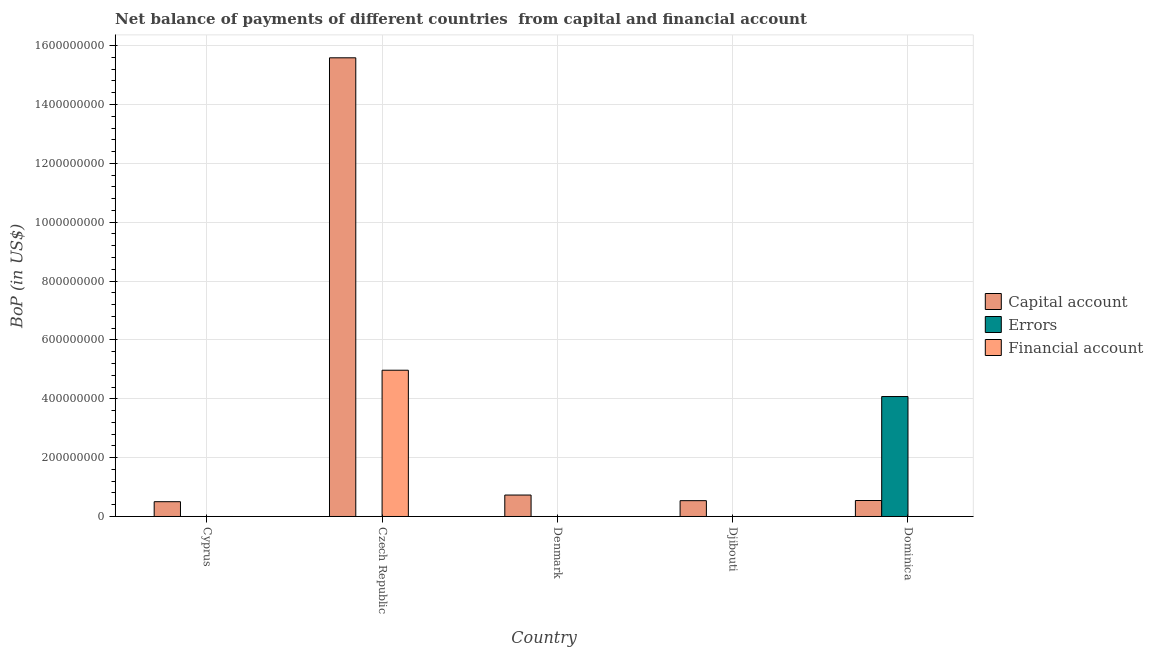How many different coloured bars are there?
Provide a short and direct response. 3. Are the number of bars per tick equal to the number of legend labels?
Make the answer very short. No. Are the number of bars on each tick of the X-axis equal?
Your answer should be very brief. No. How many bars are there on the 3rd tick from the right?
Your response must be concise. 1. What is the label of the 1st group of bars from the left?
Your answer should be compact. Cyprus. In how many cases, is the number of bars for a given country not equal to the number of legend labels?
Ensure brevity in your answer.  5. What is the amount of errors in Cyprus?
Make the answer very short. 0. Across all countries, what is the maximum amount of net capital account?
Offer a very short reply. 1.56e+09. In which country was the amount of net capital account maximum?
Offer a very short reply. Czech Republic. What is the total amount of net capital account in the graph?
Offer a very short reply. 1.79e+09. What is the difference between the amount of net capital account in Denmark and that in Dominica?
Provide a succinct answer. 1.85e+07. What is the average amount of errors per country?
Offer a very short reply. 8.15e+07. In how many countries, is the amount of financial account greater than 680000000 US$?
Provide a succinct answer. 0. Is the amount of net capital account in Cyprus less than that in Dominica?
Your answer should be compact. Yes. What is the difference between the highest and the second highest amount of net capital account?
Your answer should be compact. 1.49e+09. What is the difference between the highest and the lowest amount of financial account?
Keep it short and to the point. 4.97e+08. Are all the bars in the graph horizontal?
Your answer should be very brief. No. Does the graph contain any zero values?
Make the answer very short. Yes. Does the graph contain grids?
Provide a succinct answer. Yes. Where does the legend appear in the graph?
Your answer should be compact. Center right. How many legend labels are there?
Offer a very short reply. 3. What is the title of the graph?
Provide a short and direct response. Net balance of payments of different countries  from capital and financial account. What is the label or title of the X-axis?
Give a very brief answer. Country. What is the label or title of the Y-axis?
Your answer should be compact. BoP (in US$). What is the BoP (in US$) of Capital account in Cyprus?
Your response must be concise. 5.03e+07. What is the BoP (in US$) in Errors in Cyprus?
Give a very brief answer. 0. What is the BoP (in US$) in Financial account in Cyprus?
Give a very brief answer. 0. What is the BoP (in US$) in Capital account in Czech Republic?
Your answer should be compact. 1.56e+09. What is the BoP (in US$) in Errors in Czech Republic?
Your answer should be very brief. 0. What is the BoP (in US$) of Financial account in Czech Republic?
Your answer should be very brief. 4.97e+08. What is the BoP (in US$) in Capital account in Denmark?
Make the answer very short. 7.29e+07. What is the BoP (in US$) in Errors in Denmark?
Make the answer very short. 0. What is the BoP (in US$) of Capital account in Djibouti?
Your answer should be compact. 5.37e+07. What is the BoP (in US$) of Financial account in Djibouti?
Give a very brief answer. 0. What is the BoP (in US$) of Capital account in Dominica?
Offer a very short reply. 5.43e+07. What is the BoP (in US$) in Errors in Dominica?
Ensure brevity in your answer.  4.08e+08. Across all countries, what is the maximum BoP (in US$) in Capital account?
Provide a short and direct response. 1.56e+09. Across all countries, what is the maximum BoP (in US$) of Errors?
Offer a very short reply. 4.08e+08. Across all countries, what is the maximum BoP (in US$) in Financial account?
Keep it short and to the point. 4.97e+08. Across all countries, what is the minimum BoP (in US$) of Capital account?
Ensure brevity in your answer.  5.03e+07. What is the total BoP (in US$) in Capital account in the graph?
Provide a short and direct response. 1.79e+09. What is the total BoP (in US$) of Errors in the graph?
Make the answer very short. 4.08e+08. What is the total BoP (in US$) of Financial account in the graph?
Provide a short and direct response. 4.97e+08. What is the difference between the BoP (in US$) in Capital account in Cyprus and that in Czech Republic?
Your answer should be very brief. -1.51e+09. What is the difference between the BoP (in US$) of Capital account in Cyprus and that in Denmark?
Offer a very short reply. -2.26e+07. What is the difference between the BoP (in US$) in Capital account in Cyprus and that in Djibouti?
Your answer should be compact. -3.47e+06. What is the difference between the BoP (in US$) in Capital account in Cyprus and that in Dominica?
Your response must be concise. -4.03e+06. What is the difference between the BoP (in US$) in Capital account in Czech Republic and that in Denmark?
Give a very brief answer. 1.49e+09. What is the difference between the BoP (in US$) of Capital account in Czech Republic and that in Djibouti?
Keep it short and to the point. 1.50e+09. What is the difference between the BoP (in US$) of Capital account in Czech Republic and that in Dominica?
Keep it short and to the point. 1.50e+09. What is the difference between the BoP (in US$) in Capital account in Denmark and that in Djibouti?
Offer a very short reply. 1.91e+07. What is the difference between the BoP (in US$) in Capital account in Denmark and that in Dominica?
Give a very brief answer. 1.85e+07. What is the difference between the BoP (in US$) in Capital account in Djibouti and that in Dominica?
Provide a short and direct response. -5.60e+05. What is the difference between the BoP (in US$) in Capital account in Cyprus and the BoP (in US$) in Financial account in Czech Republic?
Provide a succinct answer. -4.47e+08. What is the difference between the BoP (in US$) of Capital account in Cyprus and the BoP (in US$) of Errors in Dominica?
Give a very brief answer. -3.57e+08. What is the difference between the BoP (in US$) of Capital account in Czech Republic and the BoP (in US$) of Errors in Dominica?
Give a very brief answer. 1.15e+09. What is the difference between the BoP (in US$) in Capital account in Denmark and the BoP (in US$) in Errors in Dominica?
Keep it short and to the point. -3.35e+08. What is the difference between the BoP (in US$) of Capital account in Djibouti and the BoP (in US$) of Errors in Dominica?
Keep it short and to the point. -3.54e+08. What is the average BoP (in US$) of Capital account per country?
Give a very brief answer. 3.58e+08. What is the average BoP (in US$) in Errors per country?
Provide a succinct answer. 8.15e+07. What is the average BoP (in US$) of Financial account per country?
Your response must be concise. 9.94e+07. What is the difference between the BoP (in US$) of Capital account and BoP (in US$) of Financial account in Czech Republic?
Your response must be concise. 1.06e+09. What is the difference between the BoP (in US$) in Capital account and BoP (in US$) in Errors in Dominica?
Make the answer very short. -3.53e+08. What is the ratio of the BoP (in US$) of Capital account in Cyprus to that in Czech Republic?
Ensure brevity in your answer.  0.03. What is the ratio of the BoP (in US$) of Capital account in Cyprus to that in Denmark?
Your response must be concise. 0.69. What is the ratio of the BoP (in US$) of Capital account in Cyprus to that in Djibouti?
Make the answer very short. 0.94. What is the ratio of the BoP (in US$) in Capital account in Cyprus to that in Dominica?
Offer a terse response. 0.93. What is the ratio of the BoP (in US$) in Capital account in Czech Republic to that in Denmark?
Your response must be concise. 21.39. What is the ratio of the BoP (in US$) of Capital account in Czech Republic to that in Djibouti?
Provide a short and direct response. 29. What is the ratio of the BoP (in US$) in Capital account in Czech Republic to that in Dominica?
Your answer should be very brief. 28.7. What is the ratio of the BoP (in US$) of Capital account in Denmark to that in Djibouti?
Keep it short and to the point. 1.36. What is the ratio of the BoP (in US$) of Capital account in Denmark to that in Dominica?
Your answer should be compact. 1.34. What is the ratio of the BoP (in US$) of Capital account in Djibouti to that in Dominica?
Your response must be concise. 0.99. What is the difference between the highest and the second highest BoP (in US$) in Capital account?
Provide a short and direct response. 1.49e+09. What is the difference between the highest and the lowest BoP (in US$) in Capital account?
Provide a succinct answer. 1.51e+09. What is the difference between the highest and the lowest BoP (in US$) of Errors?
Give a very brief answer. 4.08e+08. What is the difference between the highest and the lowest BoP (in US$) in Financial account?
Give a very brief answer. 4.97e+08. 